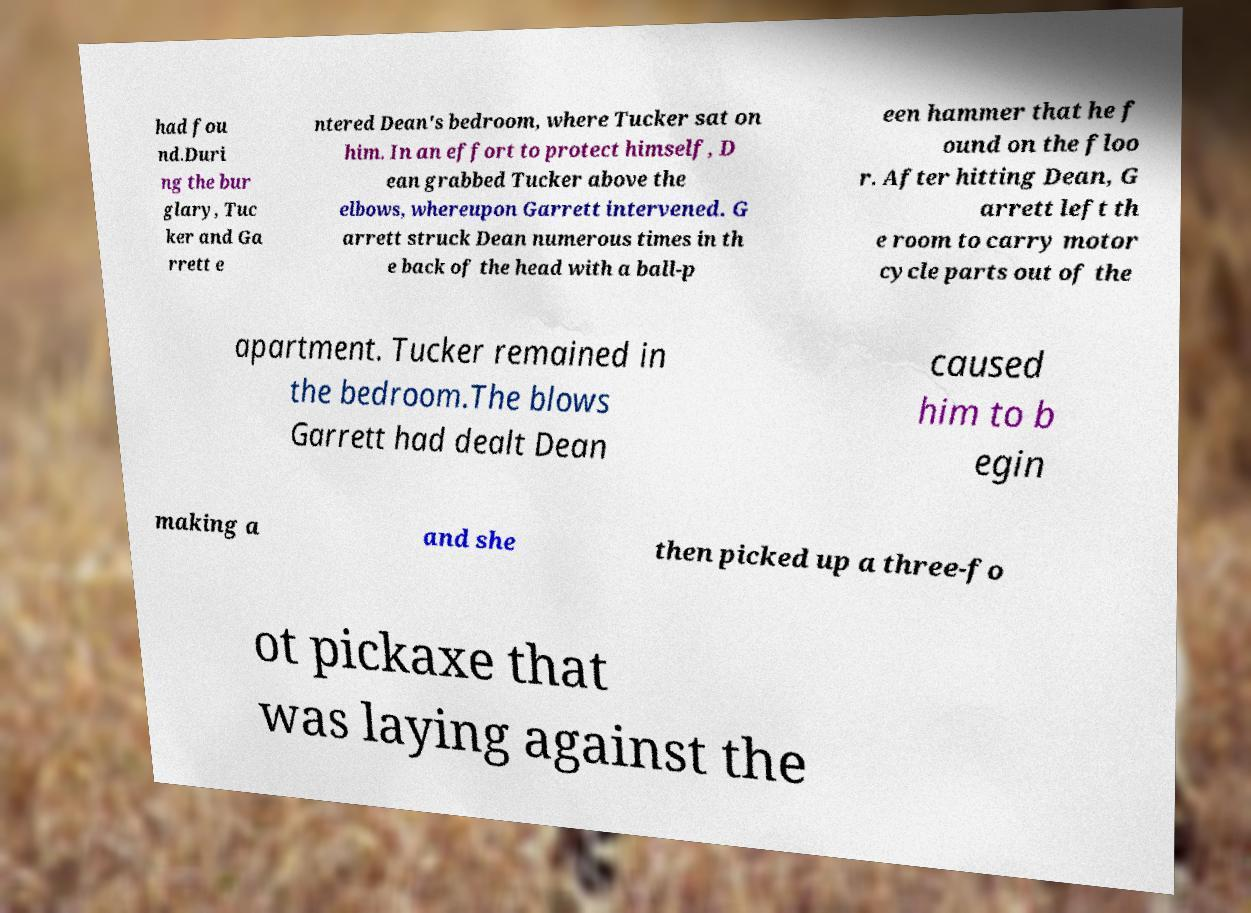Could you extract and type out the text from this image? had fou nd.Duri ng the bur glary, Tuc ker and Ga rrett e ntered Dean's bedroom, where Tucker sat on him. In an effort to protect himself, D ean grabbed Tucker above the elbows, whereupon Garrett intervened. G arrett struck Dean numerous times in th e back of the head with a ball-p een hammer that he f ound on the floo r. After hitting Dean, G arrett left th e room to carry motor cycle parts out of the apartment. Tucker remained in the bedroom.The blows Garrett had dealt Dean caused him to b egin making a and she then picked up a three-fo ot pickaxe that was laying against the 